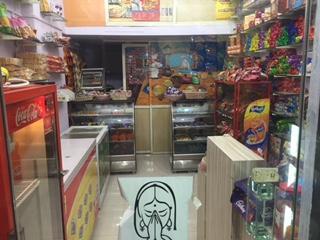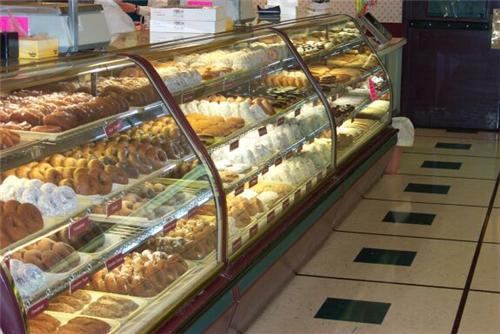The first image is the image on the left, the second image is the image on the right. Examine the images to the left and right. Is the description "The bakery's name is visible in at least one image." accurate? Answer yes or no. No. The first image is the image on the left, the second image is the image on the right. Evaluate the accuracy of this statement regarding the images: "In at least one image there is no less than 4 men standing behind the baked goods counter.". Is it true? Answer yes or no. No. 